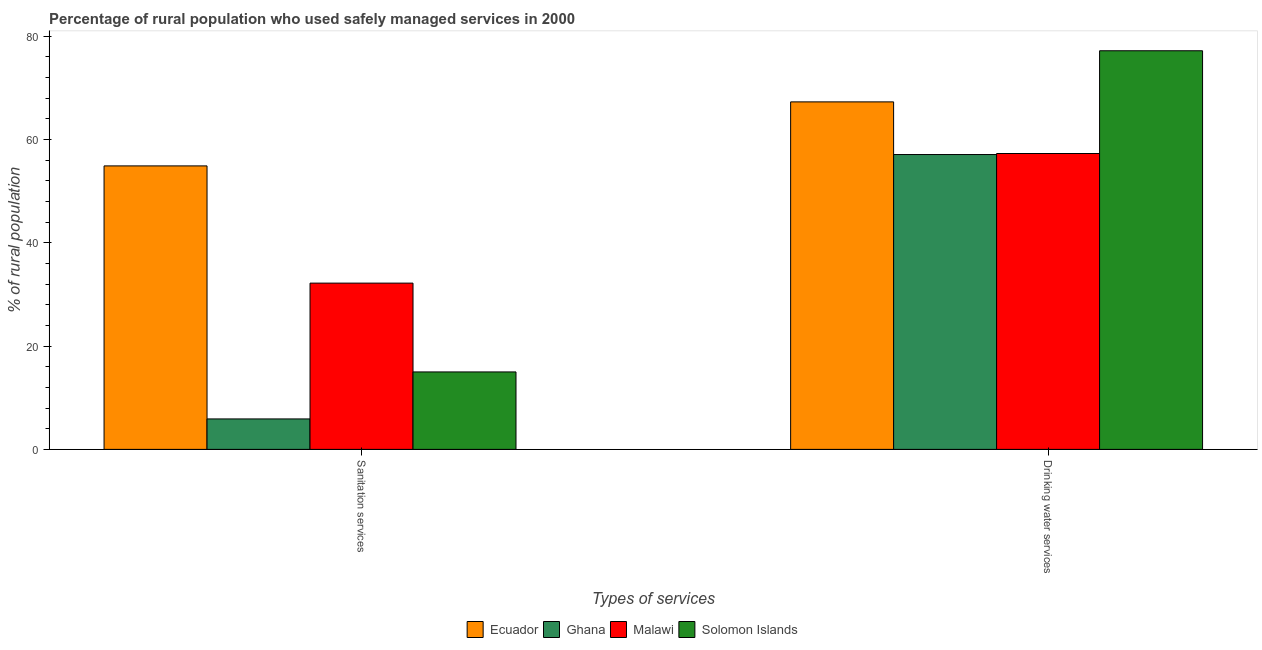Are the number of bars per tick equal to the number of legend labels?
Give a very brief answer. Yes. Are the number of bars on each tick of the X-axis equal?
Ensure brevity in your answer.  Yes. How many bars are there on the 1st tick from the right?
Offer a very short reply. 4. What is the label of the 1st group of bars from the left?
Ensure brevity in your answer.  Sanitation services. What is the percentage of rural population who used sanitation services in Solomon Islands?
Provide a succinct answer. 15. Across all countries, what is the maximum percentage of rural population who used sanitation services?
Offer a terse response. 54.9. Across all countries, what is the minimum percentage of rural population who used drinking water services?
Your answer should be compact. 57.1. In which country was the percentage of rural population who used drinking water services maximum?
Provide a short and direct response. Solomon Islands. What is the total percentage of rural population who used drinking water services in the graph?
Your answer should be very brief. 258.9. What is the difference between the percentage of rural population who used drinking water services in Malawi and that in Ghana?
Your response must be concise. 0.2. What is the difference between the percentage of rural population who used drinking water services in Solomon Islands and the percentage of rural population who used sanitation services in Ecuador?
Provide a short and direct response. 22.3. What is the average percentage of rural population who used drinking water services per country?
Keep it short and to the point. 64.72. What is the difference between the percentage of rural population who used sanitation services and percentage of rural population who used drinking water services in Solomon Islands?
Offer a very short reply. -62.2. In how many countries, is the percentage of rural population who used drinking water services greater than 24 %?
Provide a succinct answer. 4. What is the ratio of the percentage of rural population who used drinking water services in Malawi to that in Ecuador?
Your response must be concise. 0.85. What does the 2nd bar from the left in Sanitation services represents?
Your answer should be very brief. Ghana. What does the 2nd bar from the right in Drinking water services represents?
Make the answer very short. Malawi. How many bars are there?
Make the answer very short. 8. How many countries are there in the graph?
Your answer should be very brief. 4. Are the values on the major ticks of Y-axis written in scientific E-notation?
Your answer should be very brief. No. How are the legend labels stacked?
Give a very brief answer. Horizontal. What is the title of the graph?
Make the answer very short. Percentage of rural population who used safely managed services in 2000. Does "Philippines" appear as one of the legend labels in the graph?
Provide a short and direct response. No. What is the label or title of the X-axis?
Give a very brief answer. Types of services. What is the label or title of the Y-axis?
Your response must be concise. % of rural population. What is the % of rural population of Ecuador in Sanitation services?
Ensure brevity in your answer.  54.9. What is the % of rural population in Malawi in Sanitation services?
Offer a terse response. 32.2. What is the % of rural population in Solomon Islands in Sanitation services?
Your response must be concise. 15. What is the % of rural population of Ecuador in Drinking water services?
Keep it short and to the point. 67.3. What is the % of rural population in Ghana in Drinking water services?
Ensure brevity in your answer.  57.1. What is the % of rural population of Malawi in Drinking water services?
Your answer should be compact. 57.3. What is the % of rural population in Solomon Islands in Drinking water services?
Offer a very short reply. 77.2. Across all Types of services, what is the maximum % of rural population of Ecuador?
Your answer should be compact. 67.3. Across all Types of services, what is the maximum % of rural population in Ghana?
Keep it short and to the point. 57.1. Across all Types of services, what is the maximum % of rural population in Malawi?
Make the answer very short. 57.3. Across all Types of services, what is the maximum % of rural population in Solomon Islands?
Provide a succinct answer. 77.2. Across all Types of services, what is the minimum % of rural population of Ecuador?
Your answer should be very brief. 54.9. Across all Types of services, what is the minimum % of rural population of Malawi?
Offer a terse response. 32.2. What is the total % of rural population in Ecuador in the graph?
Ensure brevity in your answer.  122.2. What is the total % of rural population of Malawi in the graph?
Offer a terse response. 89.5. What is the total % of rural population in Solomon Islands in the graph?
Your response must be concise. 92.2. What is the difference between the % of rural population in Ghana in Sanitation services and that in Drinking water services?
Your answer should be compact. -51.2. What is the difference between the % of rural population of Malawi in Sanitation services and that in Drinking water services?
Keep it short and to the point. -25.1. What is the difference between the % of rural population of Solomon Islands in Sanitation services and that in Drinking water services?
Offer a very short reply. -62.2. What is the difference between the % of rural population of Ecuador in Sanitation services and the % of rural population of Solomon Islands in Drinking water services?
Provide a short and direct response. -22.3. What is the difference between the % of rural population in Ghana in Sanitation services and the % of rural population in Malawi in Drinking water services?
Make the answer very short. -51.4. What is the difference between the % of rural population in Ghana in Sanitation services and the % of rural population in Solomon Islands in Drinking water services?
Give a very brief answer. -71.3. What is the difference between the % of rural population in Malawi in Sanitation services and the % of rural population in Solomon Islands in Drinking water services?
Your response must be concise. -45. What is the average % of rural population of Ecuador per Types of services?
Offer a very short reply. 61.1. What is the average % of rural population in Ghana per Types of services?
Give a very brief answer. 31.5. What is the average % of rural population in Malawi per Types of services?
Provide a succinct answer. 44.75. What is the average % of rural population of Solomon Islands per Types of services?
Your response must be concise. 46.1. What is the difference between the % of rural population of Ecuador and % of rural population of Ghana in Sanitation services?
Make the answer very short. 49. What is the difference between the % of rural population in Ecuador and % of rural population in Malawi in Sanitation services?
Provide a succinct answer. 22.7. What is the difference between the % of rural population of Ecuador and % of rural population of Solomon Islands in Sanitation services?
Offer a very short reply. 39.9. What is the difference between the % of rural population of Ghana and % of rural population of Malawi in Sanitation services?
Provide a short and direct response. -26.3. What is the difference between the % of rural population of Ghana and % of rural population of Solomon Islands in Sanitation services?
Provide a succinct answer. -9.1. What is the difference between the % of rural population in Malawi and % of rural population in Solomon Islands in Sanitation services?
Your response must be concise. 17.2. What is the difference between the % of rural population of Ecuador and % of rural population of Ghana in Drinking water services?
Provide a short and direct response. 10.2. What is the difference between the % of rural population in Ecuador and % of rural population in Malawi in Drinking water services?
Your answer should be compact. 10. What is the difference between the % of rural population in Ecuador and % of rural population in Solomon Islands in Drinking water services?
Your response must be concise. -9.9. What is the difference between the % of rural population of Ghana and % of rural population of Solomon Islands in Drinking water services?
Provide a succinct answer. -20.1. What is the difference between the % of rural population of Malawi and % of rural population of Solomon Islands in Drinking water services?
Provide a short and direct response. -19.9. What is the ratio of the % of rural population of Ecuador in Sanitation services to that in Drinking water services?
Your response must be concise. 0.82. What is the ratio of the % of rural population in Ghana in Sanitation services to that in Drinking water services?
Keep it short and to the point. 0.1. What is the ratio of the % of rural population of Malawi in Sanitation services to that in Drinking water services?
Offer a very short reply. 0.56. What is the ratio of the % of rural population in Solomon Islands in Sanitation services to that in Drinking water services?
Provide a succinct answer. 0.19. What is the difference between the highest and the second highest % of rural population of Ecuador?
Provide a short and direct response. 12.4. What is the difference between the highest and the second highest % of rural population of Ghana?
Your answer should be very brief. 51.2. What is the difference between the highest and the second highest % of rural population of Malawi?
Ensure brevity in your answer.  25.1. What is the difference between the highest and the second highest % of rural population in Solomon Islands?
Make the answer very short. 62.2. What is the difference between the highest and the lowest % of rural population in Ghana?
Your answer should be compact. 51.2. What is the difference between the highest and the lowest % of rural population in Malawi?
Keep it short and to the point. 25.1. What is the difference between the highest and the lowest % of rural population of Solomon Islands?
Your response must be concise. 62.2. 